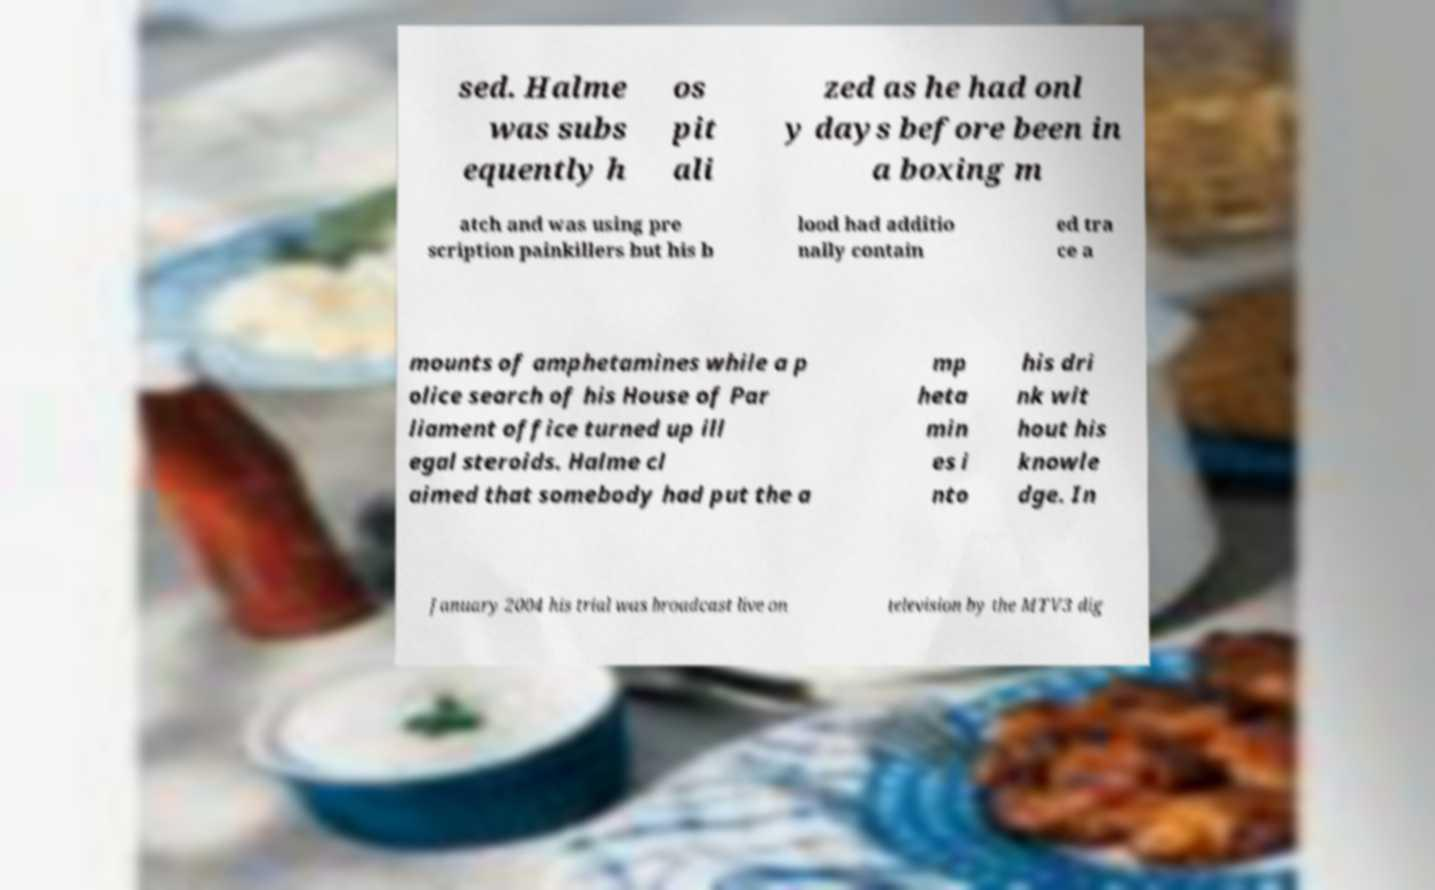What messages or text are displayed in this image? I need them in a readable, typed format. sed. Halme was subs equently h os pit ali zed as he had onl y days before been in a boxing m atch and was using pre scription painkillers but his b lood had additio nally contain ed tra ce a mounts of amphetamines while a p olice search of his House of Par liament office turned up ill egal steroids. Halme cl aimed that somebody had put the a mp heta min es i nto his dri nk wit hout his knowle dge. In January 2004 his trial was broadcast live on television by the MTV3 dig 